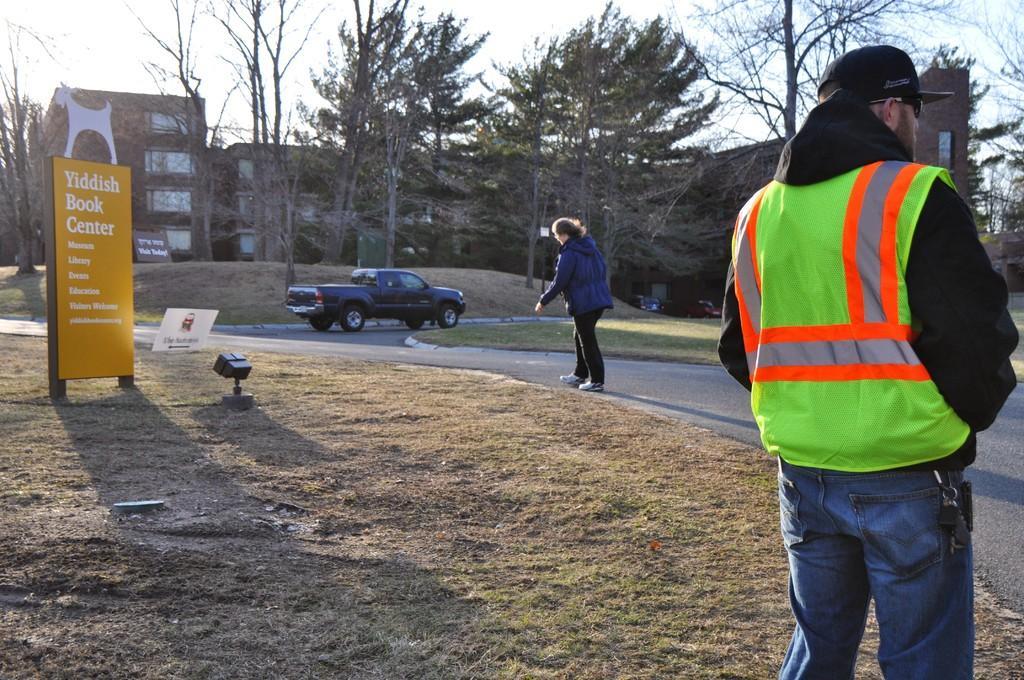Could you give a brief overview of what you see in this image? In this image we can see many trees and buildings. There are few cars in the image. There are two persons in the image. There is a sky in the image. There are advertising boards in the image. 